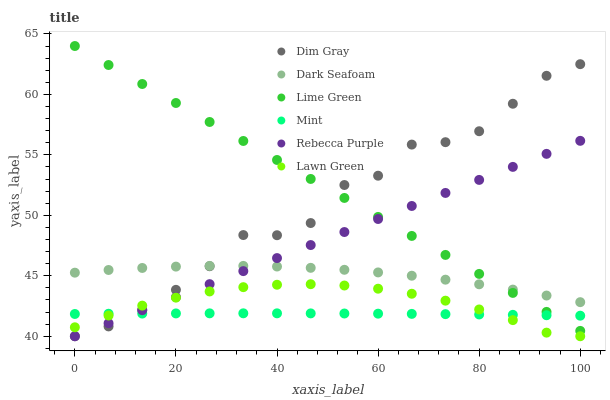Does Mint have the minimum area under the curve?
Answer yes or no. Yes. Does Lime Green have the maximum area under the curve?
Answer yes or no. Yes. Does Dim Gray have the minimum area under the curve?
Answer yes or no. No. Does Dim Gray have the maximum area under the curve?
Answer yes or no. No. Is Rebecca Purple the smoothest?
Answer yes or no. Yes. Is Dim Gray the roughest?
Answer yes or no. Yes. Is Lime Green the smoothest?
Answer yes or no. No. Is Lime Green the roughest?
Answer yes or no. No. Does Lawn Green have the lowest value?
Answer yes or no. Yes. Does Lime Green have the lowest value?
Answer yes or no. No. Does Lime Green have the highest value?
Answer yes or no. Yes. Does Dim Gray have the highest value?
Answer yes or no. No. Is Lawn Green less than Dark Seafoam?
Answer yes or no. Yes. Is Dark Seafoam greater than Mint?
Answer yes or no. Yes. Does Mint intersect Dim Gray?
Answer yes or no. Yes. Is Mint less than Dim Gray?
Answer yes or no. No. Is Mint greater than Dim Gray?
Answer yes or no. No. Does Lawn Green intersect Dark Seafoam?
Answer yes or no. No. 